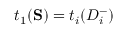<formula> <loc_0><loc_0><loc_500><loc_500>t _ { 1 } ( S ) = t _ { i } ( D _ { i } ^ { - } )</formula> 